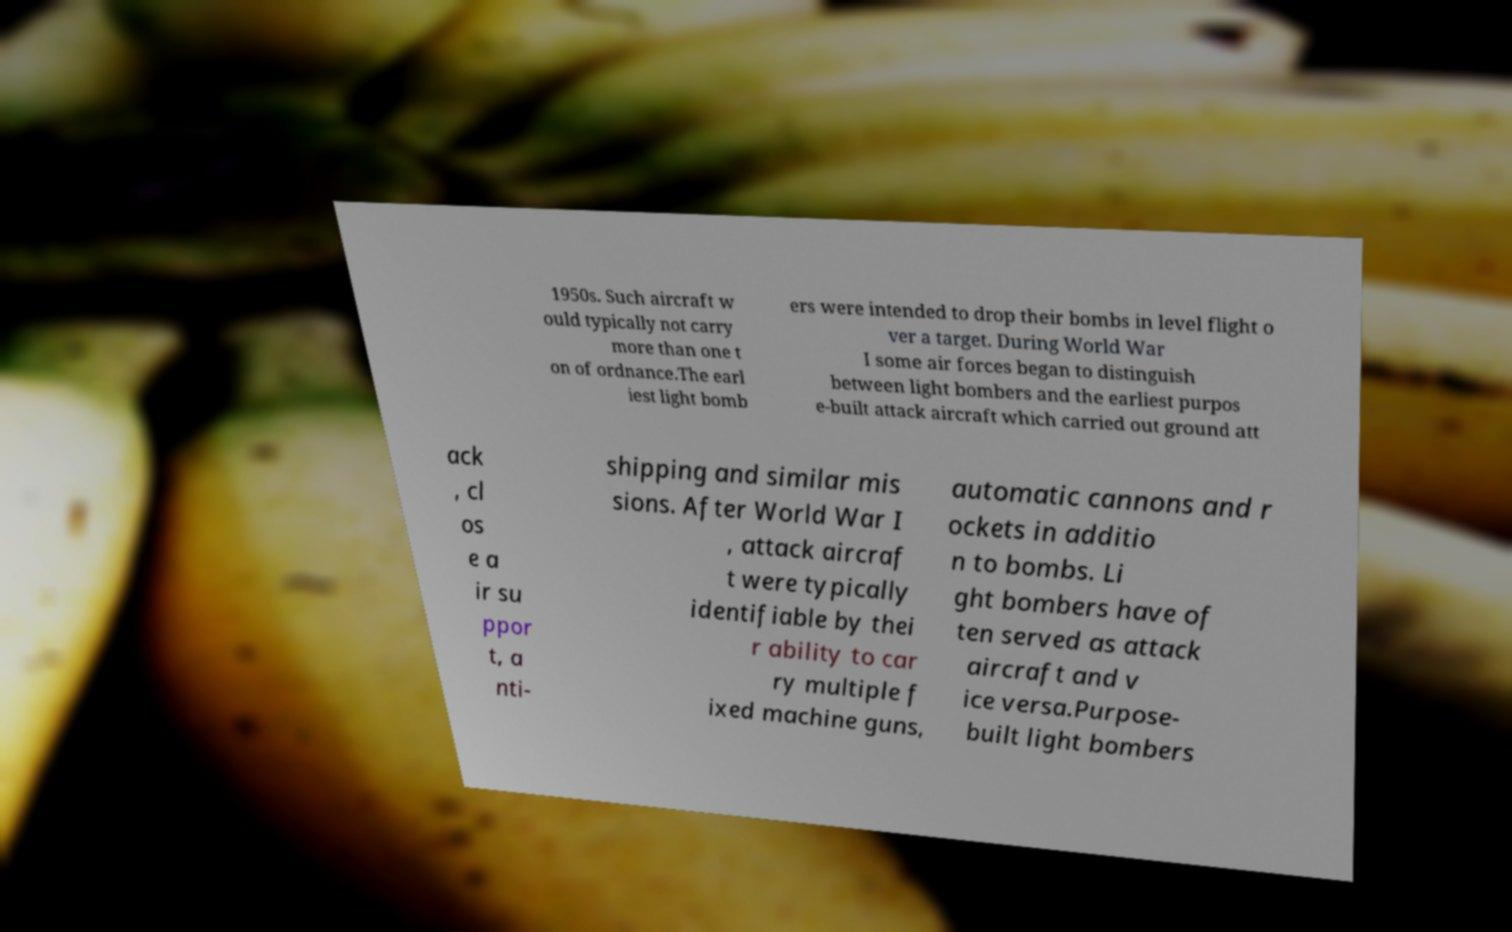Please read and relay the text visible in this image. What does it say? 1950s. Such aircraft w ould typically not carry more than one t on of ordnance.The earl iest light bomb ers were intended to drop their bombs in level flight o ver a target. During World War I some air forces began to distinguish between light bombers and the earliest purpos e-built attack aircraft which carried out ground att ack , cl os e a ir su ppor t, a nti- shipping and similar mis sions. After World War I , attack aircraf t were typically identifiable by thei r ability to car ry multiple f ixed machine guns, automatic cannons and r ockets in additio n to bombs. Li ght bombers have of ten served as attack aircraft and v ice versa.Purpose- built light bombers 